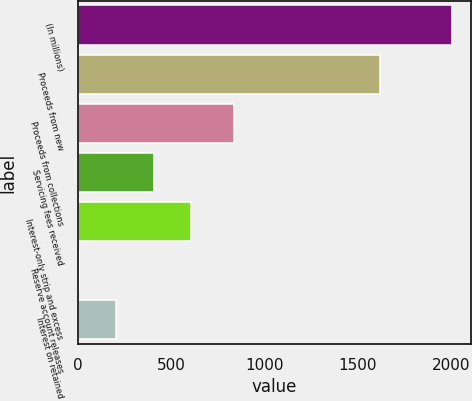Convert chart. <chart><loc_0><loc_0><loc_500><loc_500><bar_chart><fcel>(In millions)<fcel>Proceeds from new<fcel>Proceeds from collections<fcel>Servicing fees received<fcel>Interest-only strip and excess<fcel>Reserve account releases<fcel>Interest on retained<nl><fcel>2009<fcel>1622.8<fcel>840.6<fcel>406.92<fcel>607.18<fcel>6.4<fcel>206.66<nl></chart> 